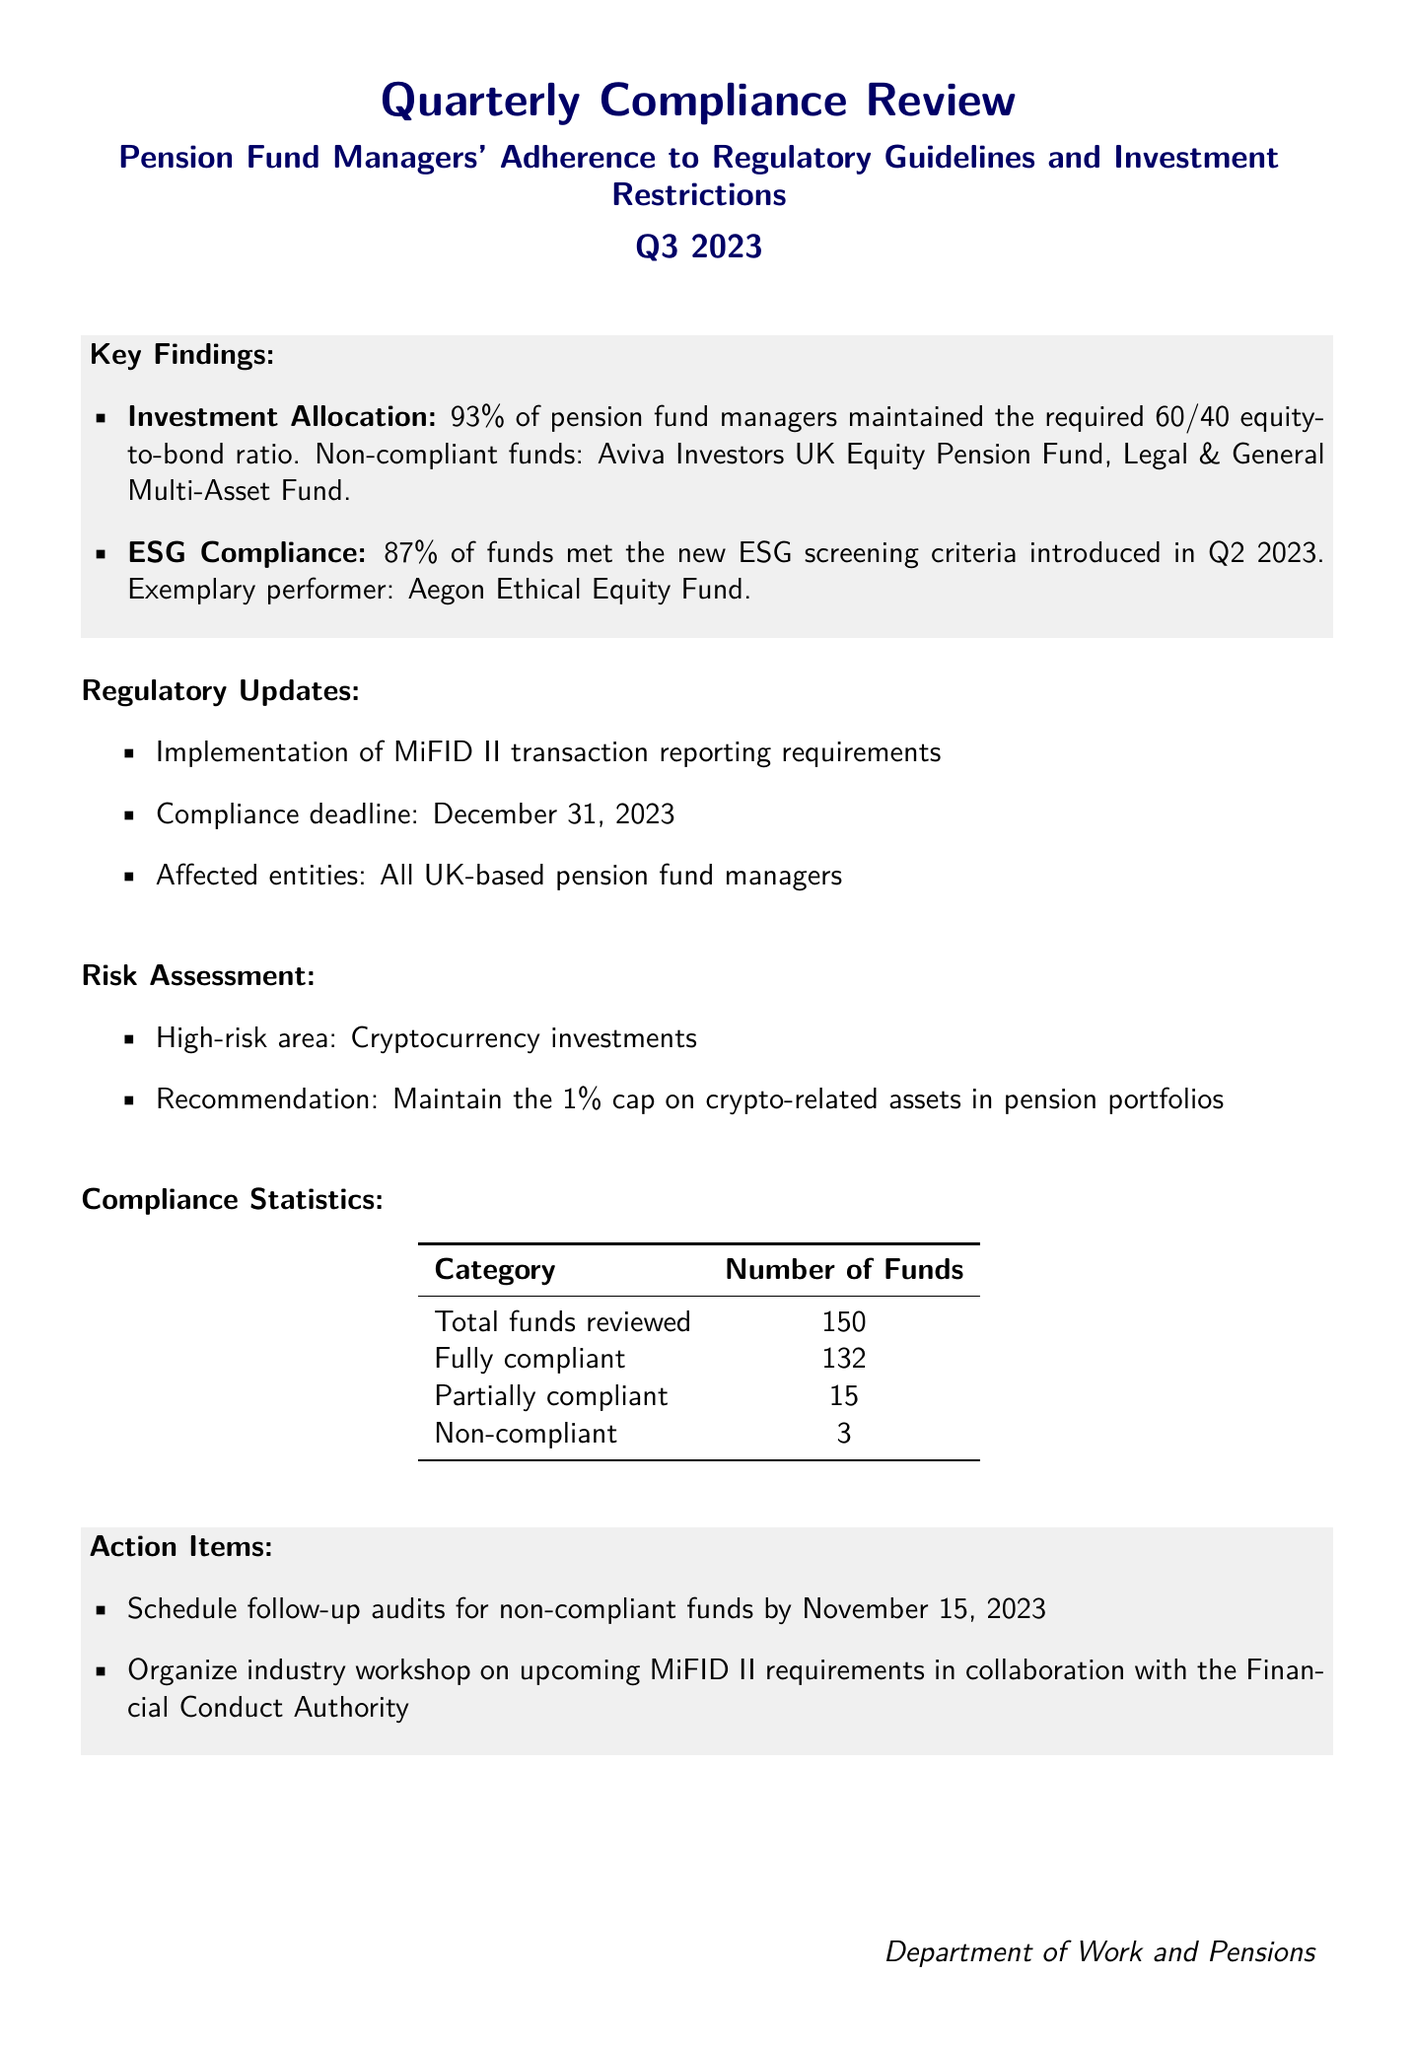What is the reporting period of the review? The reporting period indicates the specific time frame that the report covers, which is Q3 2023.
Answer: Q3 2023 How many pension fund managers were reviewed? The total number of pension funds reviewed is a key compliance statistic that is stated in the document.
Answer: 150 What percentage of pension fund managers maintained the required equity-to-bond ratio? This percentage is provided in the key findings section of the document.
Answer: 93% Which fund was identified as the exemplary performer in ESG compliance? The document mentions specific funds related to ESG compliance, with one noted as exemplary.
Answer: Aegon Ethical Equity Fund What is the deadline for compliance with MiFID II transaction reporting requirements? The compliance deadline for the new transaction reporting requirements is an important regulatory update noted in the report.
Answer: December 31, 2023 How many funds were found to be non-compliant? The compliance statistics section lists the number of non-compliant funds.
Answer: 3 What is the high-risk area identified in the risk assessment? The document specifies areas of concern regarding risks in pension fund management.
Answer: Cryptocurrency investments What action item is scheduled for non-compliant funds? The action items section outlines specific follow-up actions regarding non-compliant funds.
Answer: Follow-up audits by November 15, 2023 What percentage of funds met the new ESG screening criteria? This percentage reflects the level of compliance with recent ESG regulations.
Answer: 87% 